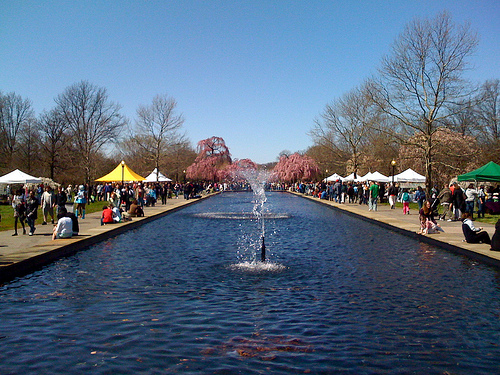<image>
Is there a tree above the water? No. The tree is not positioned above the water. The vertical arrangement shows a different relationship. Is the sky behind the tent? No. The sky is not behind the tent. From this viewpoint, the sky appears to be positioned elsewhere in the scene. 